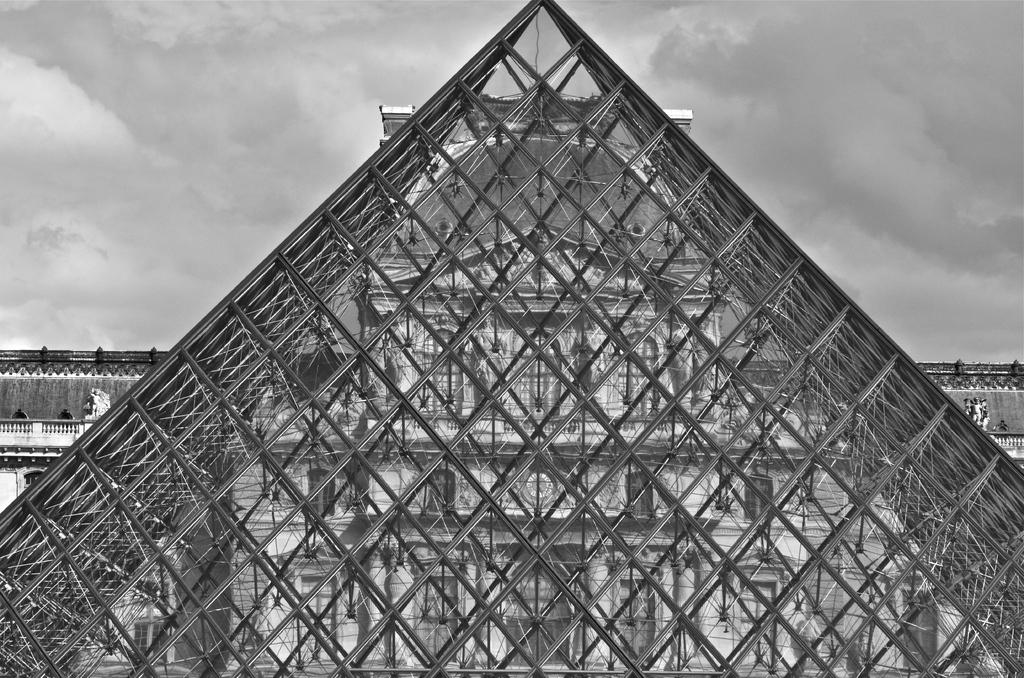What is the color scheme of the image? The image is black and white. What type of subject can be seen in the image? There is an architectural structure in the image. What can be seen in the background of the image? The sky is visible in the background of the image. How many doors made of steel can be seen in the image? There are no doors or steel mentioned in the image; it only features an architectural structure and the sky in the background. 